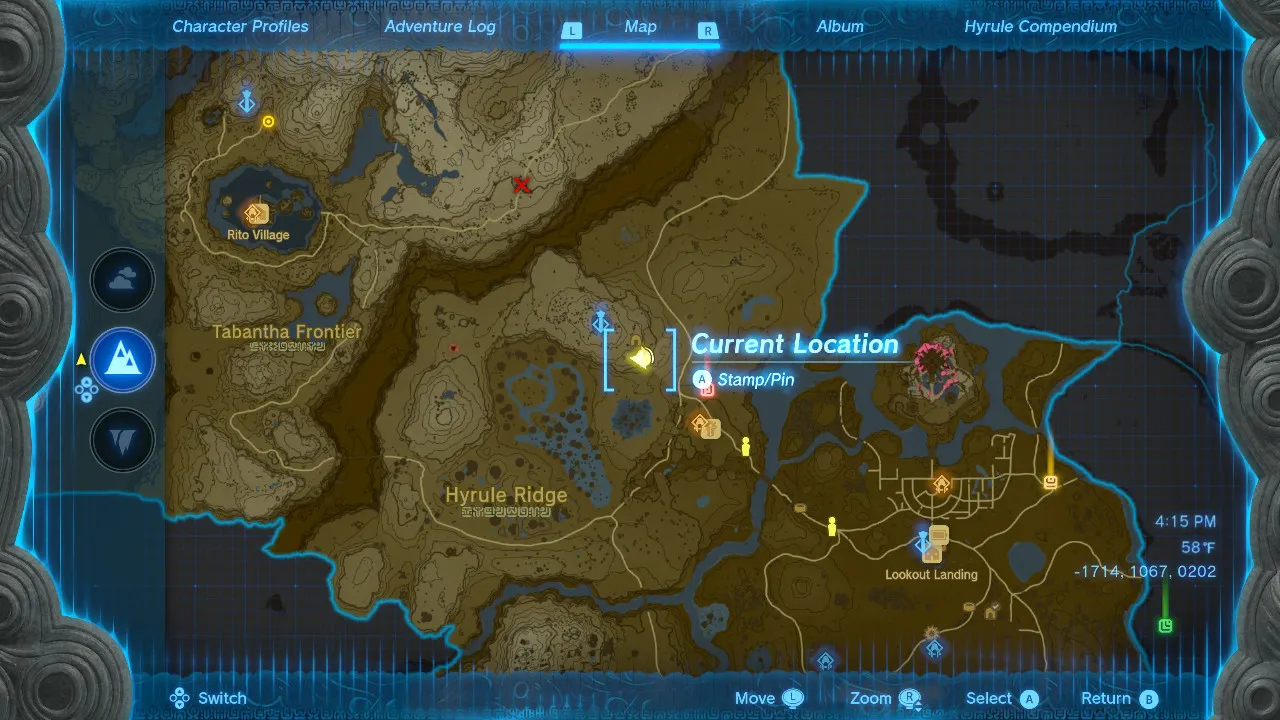Given my horse's location on this map, what is the quickest route to reach it? Please tell me the location of your horse on the map. I need more information to determine the quickest route. 